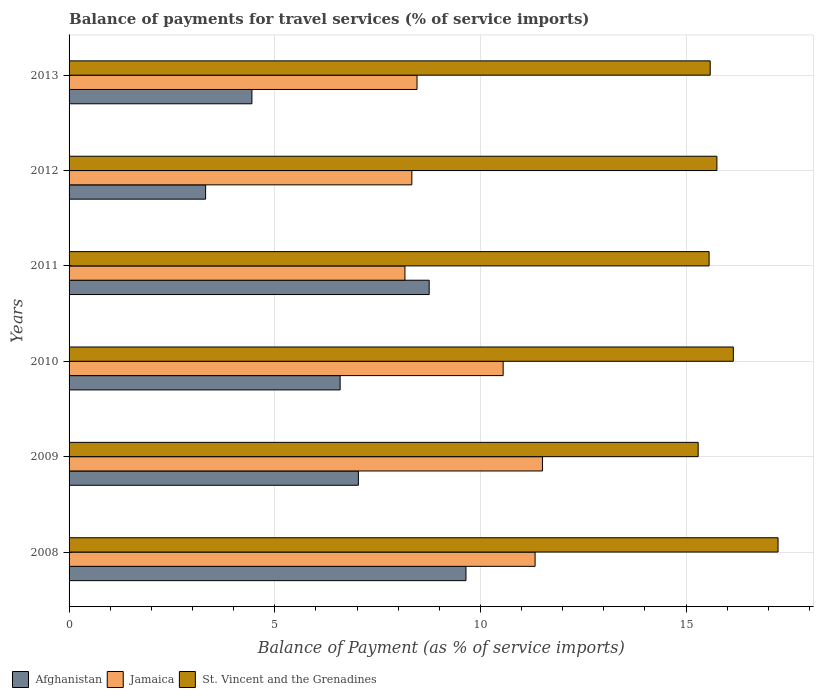How many different coloured bars are there?
Give a very brief answer. 3. How many groups of bars are there?
Your answer should be compact. 6. Are the number of bars per tick equal to the number of legend labels?
Offer a terse response. Yes. How many bars are there on the 5th tick from the top?
Your answer should be very brief. 3. How many bars are there on the 3rd tick from the bottom?
Ensure brevity in your answer.  3. What is the label of the 6th group of bars from the top?
Make the answer very short. 2008. What is the balance of payments for travel services in Jamaica in 2009?
Offer a terse response. 11.51. Across all years, what is the maximum balance of payments for travel services in St. Vincent and the Grenadines?
Keep it short and to the point. 17.24. Across all years, what is the minimum balance of payments for travel services in St. Vincent and the Grenadines?
Provide a succinct answer. 15.29. In which year was the balance of payments for travel services in Afghanistan maximum?
Offer a terse response. 2008. What is the total balance of payments for travel services in Afghanistan in the graph?
Make the answer very short. 39.79. What is the difference between the balance of payments for travel services in St. Vincent and the Grenadines in 2008 and that in 2013?
Offer a terse response. 1.65. What is the difference between the balance of payments for travel services in Jamaica in 2011 and the balance of payments for travel services in St. Vincent and the Grenadines in 2008?
Your answer should be very brief. -9.07. What is the average balance of payments for travel services in St. Vincent and the Grenadines per year?
Keep it short and to the point. 15.93. In the year 2008, what is the difference between the balance of payments for travel services in Jamaica and balance of payments for travel services in Afghanistan?
Make the answer very short. 1.68. What is the ratio of the balance of payments for travel services in Jamaica in 2008 to that in 2012?
Ensure brevity in your answer.  1.36. Is the balance of payments for travel services in St. Vincent and the Grenadines in 2011 less than that in 2012?
Your answer should be very brief. Yes. What is the difference between the highest and the second highest balance of payments for travel services in Afghanistan?
Your answer should be compact. 0.89. What is the difference between the highest and the lowest balance of payments for travel services in Afghanistan?
Your response must be concise. 6.33. In how many years, is the balance of payments for travel services in Jamaica greater than the average balance of payments for travel services in Jamaica taken over all years?
Your response must be concise. 3. What does the 1st bar from the top in 2012 represents?
Your response must be concise. St. Vincent and the Grenadines. What does the 3rd bar from the bottom in 2013 represents?
Your response must be concise. St. Vincent and the Grenadines. How many bars are there?
Keep it short and to the point. 18. What is the difference between two consecutive major ticks on the X-axis?
Your answer should be very brief. 5. Are the values on the major ticks of X-axis written in scientific E-notation?
Your answer should be very brief. No. Does the graph contain any zero values?
Provide a succinct answer. No. What is the title of the graph?
Your response must be concise. Balance of payments for travel services (% of service imports). Does "Faeroe Islands" appear as one of the legend labels in the graph?
Your response must be concise. No. What is the label or title of the X-axis?
Your response must be concise. Balance of Payment (as % of service imports). What is the label or title of the Y-axis?
Offer a very short reply. Years. What is the Balance of Payment (as % of service imports) in Afghanistan in 2008?
Your response must be concise. 9.65. What is the Balance of Payment (as % of service imports) of Jamaica in 2008?
Offer a terse response. 11.33. What is the Balance of Payment (as % of service imports) in St. Vincent and the Grenadines in 2008?
Offer a very short reply. 17.24. What is the Balance of Payment (as % of service imports) of Afghanistan in 2009?
Ensure brevity in your answer.  7.03. What is the Balance of Payment (as % of service imports) in Jamaica in 2009?
Your answer should be compact. 11.51. What is the Balance of Payment (as % of service imports) of St. Vincent and the Grenadines in 2009?
Ensure brevity in your answer.  15.29. What is the Balance of Payment (as % of service imports) in Afghanistan in 2010?
Provide a succinct answer. 6.59. What is the Balance of Payment (as % of service imports) in Jamaica in 2010?
Your response must be concise. 10.55. What is the Balance of Payment (as % of service imports) in St. Vincent and the Grenadines in 2010?
Provide a short and direct response. 16.15. What is the Balance of Payment (as % of service imports) of Afghanistan in 2011?
Offer a very short reply. 8.75. What is the Balance of Payment (as % of service imports) of Jamaica in 2011?
Your answer should be compact. 8.17. What is the Balance of Payment (as % of service imports) in St. Vincent and the Grenadines in 2011?
Give a very brief answer. 15.56. What is the Balance of Payment (as % of service imports) of Afghanistan in 2012?
Give a very brief answer. 3.32. What is the Balance of Payment (as % of service imports) of Jamaica in 2012?
Your response must be concise. 8.33. What is the Balance of Payment (as % of service imports) of St. Vincent and the Grenadines in 2012?
Provide a short and direct response. 15.75. What is the Balance of Payment (as % of service imports) in Afghanistan in 2013?
Your response must be concise. 4.45. What is the Balance of Payment (as % of service imports) in Jamaica in 2013?
Your answer should be compact. 8.46. What is the Balance of Payment (as % of service imports) in St. Vincent and the Grenadines in 2013?
Ensure brevity in your answer.  15.59. Across all years, what is the maximum Balance of Payment (as % of service imports) in Afghanistan?
Keep it short and to the point. 9.65. Across all years, what is the maximum Balance of Payment (as % of service imports) of Jamaica?
Offer a very short reply. 11.51. Across all years, what is the maximum Balance of Payment (as % of service imports) in St. Vincent and the Grenadines?
Offer a terse response. 17.24. Across all years, what is the minimum Balance of Payment (as % of service imports) of Afghanistan?
Provide a short and direct response. 3.32. Across all years, what is the minimum Balance of Payment (as % of service imports) of Jamaica?
Your answer should be very brief. 8.17. Across all years, what is the minimum Balance of Payment (as % of service imports) in St. Vincent and the Grenadines?
Keep it short and to the point. 15.29. What is the total Balance of Payment (as % of service imports) of Afghanistan in the graph?
Offer a terse response. 39.79. What is the total Balance of Payment (as % of service imports) of Jamaica in the graph?
Your answer should be compact. 58.35. What is the total Balance of Payment (as % of service imports) in St. Vincent and the Grenadines in the graph?
Your answer should be very brief. 95.57. What is the difference between the Balance of Payment (as % of service imports) in Afghanistan in 2008 and that in 2009?
Give a very brief answer. 2.62. What is the difference between the Balance of Payment (as % of service imports) of Jamaica in 2008 and that in 2009?
Make the answer very short. -0.18. What is the difference between the Balance of Payment (as % of service imports) in St. Vincent and the Grenadines in 2008 and that in 2009?
Offer a terse response. 1.94. What is the difference between the Balance of Payment (as % of service imports) of Afghanistan in 2008 and that in 2010?
Offer a terse response. 3.06. What is the difference between the Balance of Payment (as % of service imports) in Jamaica in 2008 and that in 2010?
Keep it short and to the point. 0.78. What is the difference between the Balance of Payment (as % of service imports) in St. Vincent and the Grenadines in 2008 and that in 2010?
Make the answer very short. 1.09. What is the difference between the Balance of Payment (as % of service imports) of Afghanistan in 2008 and that in 2011?
Provide a short and direct response. 0.89. What is the difference between the Balance of Payment (as % of service imports) in Jamaica in 2008 and that in 2011?
Offer a very short reply. 3.16. What is the difference between the Balance of Payment (as % of service imports) of St. Vincent and the Grenadines in 2008 and that in 2011?
Ensure brevity in your answer.  1.68. What is the difference between the Balance of Payment (as % of service imports) of Afghanistan in 2008 and that in 2012?
Provide a short and direct response. 6.33. What is the difference between the Balance of Payment (as % of service imports) of Jamaica in 2008 and that in 2012?
Make the answer very short. 3. What is the difference between the Balance of Payment (as % of service imports) of St. Vincent and the Grenadines in 2008 and that in 2012?
Offer a terse response. 1.49. What is the difference between the Balance of Payment (as % of service imports) in Afghanistan in 2008 and that in 2013?
Offer a very short reply. 5.2. What is the difference between the Balance of Payment (as % of service imports) in Jamaica in 2008 and that in 2013?
Your answer should be very brief. 2.87. What is the difference between the Balance of Payment (as % of service imports) in St. Vincent and the Grenadines in 2008 and that in 2013?
Ensure brevity in your answer.  1.65. What is the difference between the Balance of Payment (as % of service imports) in Afghanistan in 2009 and that in 2010?
Provide a succinct answer. 0.44. What is the difference between the Balance of Payment (as % of service imports) of Jamaica in 2009 and that in 2010?
Provide a short and direct response. 0.96. What is the difference between the Balance of Payment (as % of service imports) in St. Vincent and the Grenadines in 2009 and that in 2010?
Provide a succinct answer. -0.85. What is the difference between the Balance of Payment (as % of service imports) in Afghanistan in 2009 and that in 2011?
Provide a succinct answer. -1.72. What is the difference between the Balance of Payment (as % of service imports) of Jamaica in 2009 and that in 2011?
Keep it short and to the point. 3.34. What is the difference between the Balance of Payment (as % of service imports) of St. Vincent and the Grenadines in 2009 and that in 2011?
Your response must be concise. -0.27. What is the difference between the Balance of Payment (as % of service imports) in Afghanistan in 2009 and that in 2012?
Provide a short and direct response. 3.71. What is the difference between the Balance of Payment (as % of service imports) of Jamaica in 2009 and that in 2012?
Ensure brevity in your answer.  3.18. What is the difference between the Balance of Payment (as % of service imports) of St. Vincent and the Grenadines in 2009 and that in 2012?
Offer a very short reply. -0.46. What is the difference between the Balance of Payment (as % of service imports) of Afghanistan in 2009 and that in 2013?
Ensure brevity in your answer.  2.59. What is the difference between the Balance of Payment (as % of service imports) in Jamaica in 2009 and that in 2013?
Your answer should be compact. 3.05. What is the difference between the Balance of Payment (as % of service imports) of St. Vincent and the Grenadines in 2009 and that in 2013?
Your response must be concise. -0.29. What is the difference between the Balance of Payment (as % of service imports) of Afghanistan in 2010 and that in 2011?
Offer a terse response. -2.16. What is the difference between the Balance of Payment (as % of service imports) of Jamaica in 2010 and that in 2011?
Your response must be concise. 2.39. What is the difference between the Balance of Payment (as % of service imports) in St. Vincent and the Grenadines in 2010 and that in 2011?
Give a very brief answer. 0.59. What is the difference between the Balance of Payment (as % of service imports) in Afghanistan in 2010 and that in 2012?
Keep it short and to the point. 3.27. What is the difference between the Balance of Payment (as % of service imports) of Jamaica in 2010 and that in 2012?
Give a very brief answer. 2.22. What is the difference between the Balance of Payment (as % of service imports) of St. Vincent and the Grenadines in 2010 and that in 2012?
Ensure brevity in your answer.  0.4. What is the difference between the Balance of Payment (as % of service imports) of Afghanistan in 2010 and that in 2013?
Give a very brief answer. 2.14. What is the difference between the Balance of Payment (as % of service imports) of Jamaica in 2010 and that in 2013?
Offer a terse response. 2.09. What is the difference between the Balance of Payment (as % of service imports) of St. Vincent and the Grenadines in 2010 and that in 2013?
Ensure brevity in your answer.  0.56. What is the difference between the Balance of Payment (as % of service imports) in Afghanistan in 2011 and that in 2012?
Ensure brevity in your answer.  5.44. What is the difference between the Balance of Payment (as % of service imports) in Jamaica in 2011 and that in 2012?
Offer a very short reply. -0.17. What is the difference between the Balance of Payment (as % of service imports) of St. Vincent and the Grenadines in 2011 and that in 2012?
Your response must be concise. -0.19. What is the difference between the Balance of Payment (as % of service imports) in Afghanistan in 2011 and that in 2013?
Your answer should be compact. 4.31. What is the difference between the Balance of Payment (as % of service imports) in Jamaica in 2011 and that in 2013?
Give a very brief answer. -0.29. What is the difference between the Balance of Payment (as % of service imports) of St. Vincent and the Grenadines in 2011 and that in 2013?
Provide a succinct answer. -0.03. What is the difference between the Balance of Payment (as % of service imports) in Afghanistan in 2012 and that in 2013?
Your answer should be compact. -1.13. What is the difference between the Balance of Payment (as % of service imports) in Jamaica in 2012 and that in 2013?
Offer a very short reply. -0.13. What is the difference between the Balance of Payment (as % of service imports) in St. Vincent and the Grenadines in 2012 and that in 2013?
Keep it short and to the point. 0.16. What is the difference between the Balance of Payment (as % of service imports) in Afghanistan in 2008 and the Balance of Payment (as % of service imports) in Jamaica in 2009?
Offer a very short reply. -1.86. What is the difference between the Balance of Payment (as % of service imports) of Afghanistan in 2008 and the Balance of Payment (as % of service imports) of St. Vincent and the Grenadines in 2009?
Provide a short and direct response. -5.64. What is the difference between the Balance of Payment (as % of service imports) in Jamaica in 2008 and the Balance of Payment (as % of service imports) in St. Vincent and the Grenadines in 2009?
Give a very brief answer. -3.96. What is the difference between the Balance of Payment (as % of service imports) of Afghanistan in 2008 and the Balance of Payment (as % of service imports) of Jamaica in 2010?
Give a very brief answer. -0.9. What is the difference between the Balance of Payment (as % of service imports) of Afghanistan in 2008 and the Balance of Payment (as % of service imports) of St. Vincent and the Grenadines in 2010?
Keep it short and to the point. -6.5. What is the difference between the Balance of Payment (as % of service imports) of Jamaica in 2008 and the Balance of Payment (as % of service imports) of St. Vincent and the Grenadines in 2010?
Your answer should be compact. -4.82. What is the difference between the Balance of Payment (as % of service imports) in Afghanistan in 2008 and the Balance of Payment (as % of service imports) in Jamaica in 2011?
Your answer should be compact. 1.48. What is the difference between the Balance of Payment (as % of service imports) in Afghanistan in 2008 and the Balance of Payment (as % of service imports) in St. Vincent and the Grenadines in 2011?
Your response must be concise. -5.91. What is the difference between the Balance of Payment (as % of service imports) in Jamaica in 2008 and the Balance of Payment (as % of service imports) in St. Vincent and the Grenadines in 2011?
Provide a succinct answer. -4.23. What is the difference between the Balance of Payment (as % of service imports) of Afghanistan in 2008 and the Balance of Payment (as % of service imports) of Jamaica in 2012?
Your answer should be very brief. 1.32. What is the difference between the Balance of Payment (as % of service imports) of Afghanistan in 2008 and the Balance of Payment (as % of service imports) of St. Vincent and the Grenadines in 2012?
Provide a succinct answer. -6.1. What is the difference between the Balance of Payment (as % of service imports) in Jamaica in 2008 and the Balance of Payment (as % of service imports) in St. Vincent and the Grenadines in 2012?
Make the answer very short. -4.42. What is the difference between the Balance of Payment (as % of service imports) of Afghanistan in 2008 and the Balance of Payment (as % of service imports) of Jamaica in 2013?
Your response must be concise. 1.19. What is the difference between the Balance of Payment (as % of service imports) in Afghanistan in 2008 and the Balance of Payment (as % of service imports) in St. Vincent and the Grenadines in 2013?
Provide a short and direct response. -5.94. What is the difference between the Balance of Payment (as % of service imports) of Jamaica in 2008 and the Balance of Payment (as % of service imports) of St. Vincent and the Grenadines in 2013?
Your response must be concise. -4.26. What is the difference between the Balance of Payment (as % of service imports) of Afghanistan in 2009 and the Balance of Payment (as % of service imports) of Jamaica in 2010?
Your answer should be very brief. -3.52. What is the difference between the Balance of Payment (as % of service imports) of Afghanistan in 2009 and the Balance of Payment (as % of service imports) of St. Vincent and the Grenadines in 2010?
Offer a terse response. -9.12. What is the difference between the Balance of Payment (as % of service imports) in Jamaica in 2009 and the Balance of Payment (as % of service imports) in St. Vincent and the Grenadines in 2010?
Ensure brevity in your answer.  -4.64. What is the difference between the Balance of Payment (as % of service imports) in Afghanistan in 2009 and the Balance of Payment (as % of service imports) in Jamaica in 2011?
Your answer should be compact. -1.13. What is the difference between the Balance of Payment (as % of service imports) of Afghanistan in 2009 and the Balance of Payment (as % of service imports) of St. Vincent and the Grenadines in 2011?
Offer a very short reply. -8.53. What is the difference between the Balance of Payment (as % of service imports) in Jamaica in 2009 and the Balance of Payment (as % of service imports) in St. Vincent and the Grenadines in 2011?
Offer a terse response. -4.05. What is the difference between the Balance of Payment (as % of service imports) in Afghanistan in 2009 and the Balance of Payment (as % of service imports) in Jamaica in 2012?
Keep it short and to the point. -1.3. What is the difference between the Balance of Payment (as % of service imports) of Afghanistan in 2009 and the Balance of Payment (as % of service imports) of St. Vincent and the Grenadines in 2012?
Keep it short and to the point. -8.72. What is the difference between the Balance of Payment (as % of service imports) in Jamaica in 2009 and the Balance of Payment (as % of service imports) in St. Vincent and the Grenadines in 2012?
Provide a succinct answer. -4.24. What is the difference between the Balance of Payment (as % of service imports) in Afghanistan in 2009 and the Balance of Payment (as % of service imports) in Jamaica in 2013?
Your answer should be compact. -1.43. What is the difference between the Balance of Payment (as % of service imports) in Afghanistan in 2009 and the Balance of Payment (as % of service imports) in St. Vincent and the Grenadines in 2013?
Your response must be concise. -8.55. What is the difference between the Balance of Payment (as % of service imports) in Jamaica in 2009 and the Balance of Payment (as % of service imports) in St. Vincent and the Grenadines in 2013?
Your answer should be compact. -4.08. What is the difference between the Balance of Payment (as % of service imports) of Afghanistan in 2010 and the Balance of Payment (as % of service imports) of Jamaica in 2011?
Offer a terse response. -1.58. What is the difference between the Balance of Payment (as % of service imports) of Afghanistan in 2010 and the Balance of Payment (as % of service imports) of St. Vincent and the Grenadines in 2011?
Keep it short and to the point. -8.97. What is the difference between the Balance of Payment (as % of service imports) in Jamaica in 2010 and the Balance of Payment (as % of service imports) in St. Vincent and the Grenadines in 2011?
Keep it short and to the point. -5.01. What is the difference between the Balance of Payment (as % of service imports) of Afghanistan in 2010 and the Balance of Payment (as % of service imports) of Jamaica in 2012?
Your response must be concise. -1.74. What is the difference between the Balance of Payment (as % of service imports) of Afghanistan in 2010 and the Balance of Payment (as % of service imports) of St. Vincent and the Grenadines in 2012?
Keep it short and to the point. -9.16. What is the difference between the Balance of Payment (as % of service imports) of Jamaica in 2010 and the Balance of Payment (as % of service imports) of St. Vincent and the Grenadines in 2012?
Provide a short and direct response. -5.2. What is the difference between the Balance of Payment (as % of service imports) in Afghanistan in 2010 and the Balance of Payment (as % of service imports) in Jamaica in 2013?
Your response must be concise. -1.87. What is the difference between the Balance of Payment (as % of service imports) in Afghanistan in 2010 and the Balance of Payment (as % of service imports) in St. Vincent and the Grenadines in 2013?
Offer a very short reply. -9. What is the difference between the Balance of Payment (as % of service imports) in Jamaica in 2010 and the Balance of Payment (as % of service imports) in St. Vincent and the Grenadines in 2013?
Make the answer very short. -5.03. What is the difference between the Balance of Payment (as % of service imports) of Afghanistan in 2011 and the Balance of Payment (as % of service imports) of Jamaica in 2012?
Give a very brief answer. 0.42. What is the difference between the Balance of Payment (as % of service imports) in Afghanistan in 2011 and the Balance of Payment (as % of service imports) in St. Vincent and the Grenadines in 2012?
Your answer should be compact. -6.99. What is the difference between the Balance of Payment (as % of service imports) of Jamaica in 2011 and the Balance of Payment (as % of service imports) of St. Vincent and the Grenadines in 2012?
Your answer should be very brief. -7.58. What is the difference between the Balance of Payment (as % of service imports) in Afghanistan in 2011 and the Balance of Payment (as % of service imports) in Jamaica in 2013?
Provide a short and direct response. 0.3. What is the difference between the Balance of Payment (as % of service imports) in Afghanistan in 2011 and the Balance of Payment (as % of service imports) in St. Vincent and the Grenadines in 2013?
Your answer should be very brief. -6.83. What is the difference between the Balance of Payment (as % of service imports) of Jamaica in 2011 and the Balance of Payment (as % of service imports) of St. Vincent and the Grenadines in 2013?
Your answer should be compact. -7.42. What is the difference between the Balance of Payment (as % of service imports) in Afghanistan in 2012 and the Balance of Payment (as % of service imports) in Jamaica in 2013?
Make the answer very short. -5.14. What is the difference between the Balance of Payment (as % of service imports) of Afghanistan in 2012 and the Balance of Payment (as % of service imports) of St. Vincent and the Grenadines in 2013?
Give a very brief answer. -12.27. What is the difference between the Balance of Payment (as % of service imports) in Jamaica in 2012 and the Balance of Payment (as % of service imports) in St. Vincent and the Grenadines in 2013?
Make the answer very short. -7.25. What is the average Balance of Payment (as % of service imports) in Afghanistan per year?
Ensure brevity in your answer.  6.63. What is the average Balance of Payment (as % of service imports) of Jamaica per year?
Provide a succinct answer. 9.72. What is the average Balance of Payment (as % of service imports) of St. Vincent and the Grenadines per year?
Your answer should be very brief. 15.93. In the year 2008, what is the difference between the Balance of Payment (as % of service imports) of Afghanistan and Balance of Payment (as % of service imports) of Jamaica?
Provide a short and direct response. -1.68. In the year 2008, what is the difference between the Balance of Payment (as % of service imports) in Afghanistan and Balance of Payment (as % of service imports) in St. Vincent and the Grenadines?
Keep it short and to the point. -7.59. In the year 2008, what is the difference between the Balance of Payment (as % of service imports) in Jamaica and Balance of Payment (as % of service imports) in St. Vincent and the Grenadines?
Make the answer very short. -5.91. In the year 2009, what is the difference between the Balance of Payment (as % of service imports) in Afghanistan and Balance of Payment (as % of service imports) in Jamaica?
Offer a very short reply. -4.48. In the year 2009, what is the difference between the Balance of Payment (as % of service imports) of Afghanistan and Balance of Payment (as % of service imports) of St. Vincent and the Grenadines?
Ensure brevity in your answer.  -8.26. In the year 2009, what is the difference between the Balance of Payment (as % of service imports) of Jamaica and Balance of Payment (as % of service imports) of St. Vincent and the Grenadines?
Provide a succinct answer. -3.79. In the year 2010, what is the difference between the Balance of Payment (as % of service imports) in Afghanistan and Balance of Payment (as % of service imports) in Jamaica?
Your response must be concise. -3.96. In the year 2010, what is the difference between the Balance of Payment (as % of service imports) in Afghanistan and Balance of Payment (as % of service imports) in St. Vincent and the Grenadines?
Your answer should be compact. -9.56. In the year 2010, what is the difference between the Balance of Payment (as % of service imports) of Jamaica and Balance of Payment (as % of service imports) of St. Vincent and the Grenadines?
Make the answer very short. -5.6. In the year 2011, what is the difference between the Balance of Payment (as % of service imports) of Afghanistan and Balance of Payment (as % of service imports) of Jamaica?
Your response must be concise. 0.59. In the year 2011, what is the difference between the Balance of Payment (as % of service imports) of Afghanistan and Balance of Payment (as % of service imports) of St. Vincent and the Grenadines?
Your answer should be compact. -6.8. In the year 2011, what is the difference between the Balance of Payment (as % of service imports) of Jamaica and Balance of Payment (as % of service imports) of St. Vincent and the Grenadines?
Your response must be concise. -7.39. In the year 2012, what is the difference between the Balance of Payment (as % of service imports) of Afghanistan and Balance of Payment (as % of service imports) of Jamaica?
Ensure brevity in your answer.  -5.01. In the year 2012, what is the difference between the Balance of Payment (as % of service imports) in Afghanistan and Balance of Payment (as % of service imports) in St. Vincent and the Grenadines?
Provide a succinct answer. -12.43. In the year 2012, what is the difference between the Balance of Payment (as % of service imports) in Jamaica and Balance of Payment (as % of service imports) in St. Vincent and the Grenadines?
Offer a terse response. -7.42. In the year 2013, what is the difference between the Balance of Payment (as % of service imports) of Afghanistan and Balance of Payment (as % of service imports) of Jamaica?
Keep it short and to the point. -4.01. In the year 2013, what is the difference between the Balance of Payment (as % of service imports) in Afghanistan and Balance of Payment (as % of service imports) in St. Vincent and the Grenadines?
Your response must be concise. -11.14. In the year 2013, what is the difference between the Balance of Payment (as % of service imports) in Jamaica and Balance of Payment (as % of service imports) in St. Vincent and the Grenadines?
Ensure brevity in your answer.  -7.13. What is the ratio of the Balance of Payment (as % of service imports) of Afghanistan in 2008 to that in 2009?
Ensure brevity in your answer.  1.37. What is the ratio of the Balance of Payment (as % of service imports) of Jamaica in 2008 to that in 2009?
Ensure brevity in your answer.  0.98. What is the ratio of the Balance of Payment (as % of service imports) of St. Vincent and the Grenadines in 2008 to that in 2009?
Your answer should be compact. 1.13. What is the ratio of the Balance of Payment (as % of service imports) in Afghanistan in 2008 to that in 2010?
Ensure brevity in your answer.  1.46. What is the ratio of the Balance of Payment (as % of service imports) in Jamaica in 2008 to that in 2010?
Offer a terse response. 1.07. What is the ratio of the Balance of Payment (as % of service imports) of St. Vincent and the Grenadines in 2008 to that in 2010?
Keep it short and to the point. 1.07. What is the ratio of the Balance of Payment (as % of service imports) of Afghanistan in 2008 to that in 2011?
Offer a very short reply. 1.1. What is the ratio of the Balance of Payment (as % of service imports) in Jamaica in 2008 to that in 2011?
Offer a very short reply. 1.39. What is the ratio of the Balance of Payment (as % of service imports) of St. Vincent and the Grenadines in 2008 to that in 2011?
Give a very brief answer. 1.11. What is the ratio of the Balance of Payment (as % of service imports) in Afghanistan in 2008 to that in 2012?
Your answer should be very brief. 2.91. What is the ratio of the Balance of Payment (as % of service imports) in Jamaica in 2008 to that in 2012?
Your response must be concise. 1.36. What is the ratio of the Balance of Payment (as % of service imports) of St. Vincent and the Grenadines in 2008 to that in 2012?
Your response must be concise. 1.09. What is the ratio of the Balance of Payment (as % of service imports) of Afghanistan in 2008 to that in 2013?
Provide a short and direct response. 2.17. What is the ratio of the Balance of Payment (as % of service imports) of Jamaica in 2008 to that in 2013?
Your answer should be compact. 1.34. What is the ratio of the Balance of Payment (as % of service imports) of St. Vincent and the Grenadines in 2008 to that in 2013?
Offer a very short reply. 1.11. What is the ratio of the Balance of Payment (as % of service imports) in Afghanistan in 2009 to that in 2010?
Keep it short and to the point. 1.07. What is the ratio of the Balance of Payment (as % of service imports) of Jamaica in 2009 to that in 2010?
Your response must be concise. 1.09. What is the ratio of the Balance of Payment (as % of service imports) of St. Vincent and the Grenadines in 2009 to that in 2010?
Your answer should be very brief. 0.95. What is the ratio of the Balance of Payment (as % of service imports) in Afghanistan in 2009 to that in 2011?
Your response must be concise. 0.8. What is the ratio of the Balance of Payment (as % of service imports) in Jamaica in 2009 to that in 2011?
Provide a short and direct response. 1.41. What is the ratio of the Balance of Payment (as % of service imports) of St. Vincent and the Grenadines in 2009 to that in 2011?
Provide a short and direct response. 0.98. What is the ratio of the Balance of Payment (as % of service imports) of Afghanistan in 2009 to that in 2012?
Your answer should be very brief. 2.12. What is the ratio of the Balance of Payment (as % of service imports) of Jamaica in 2009 to that in 2012?
Your response must be concise. 1.38. What is the ratio of the Balance of Payment (as % of service imports) in St. Vincent and the Grenadines in 2009 to that in 2012?
Keep it short and to the point. 0.97. What is the ratio of the Balance of Payment (as % of service imports) of Afghanistan in 2009 to that in 2013?
Your answer should be compact. 1.58. What is the ratio of the Balance of Payment (as % of service imports) of Jamaica in 2009 to that in 2013?
Your response must be concise. 1.36. What is the ratio of the Balance of Payment (as % of service imports) of St. Vincent and the Grenadines in 2009 to that in 2013?
Ensure brevity in your answer.  0.98. What is the ratio of the Balance of Payment (as % of service imports) of Afghanistan in 2010 to that in 2011?
Your answer should be very brief. 0.75. What is the ratio of the Balance of Payment (as % of service imports) of Jamaica in 2010 to that in 2011?
Your response must be concise. 1.29. What is the ratio of the Balance of Payment (as % of service imports) of St. Vincent and the Grenadines in 2010 to that in 2011?
Your response must be concise. 1.04. What is the ratio of the Balance of Payment (as % of service imports) in Afghanistan in 2010 to that in 2012?
Your answer should be compact. 1.99. What is the ratio of the Balance of Payment (as % of service imports) in Jamaica in 2010 to that in 2012?
Ensure brevity in your answer.  1.27. What is the ratio of the Balance of Payment (as % of service imports) of St. Vincent and the Grenadines in 2010 to that in 2012?
Give a very brief answer. 1.03. What is the ratio of the Balance of Payment (as % of service imports) in Afghanistan in 2010 to that in 2013?
Your response must be concise. 1.48. What is the ratio of the Balance of Payment (as % of service imports) of Jamaica in 2010 to that in 2013?
Offer a terse response. 1.25. What is the ratio of the Balance of Payment (as % of service imports) in St. Vincent and the Grenadines in 2010 to that in 2013?
Give a very brief answer. 1.04. What is the ratio of the Balance of Payment (as % of service imports) in Afghanistan in 2011 to that in 2012?
Your answer should be very brief. 2.64. What is the ratio of the Balance of Payment (as % of service imports) of Jamaica in 2011 to that in 2012?
Provide a short and direct response. 0.98. What is the ratio of the Balance of Payment (as % of service imports) of St. Vincent and the Grenadines in 2011 to that in 2012?
Your answer should be compact. 0.99. What is the ratio of the Balance of Payment (as % of service imports) in Afghanistan in 2011 to that in 2013?
Give a very brief answer. 1.97. What is the ratio of the Balance of Payment (as % of service imports) of Jamaica in 2011 to that in 2013?
Offer a terse response. 0.97. What is the ratio of the Balance of Payment (as % of service imports) of St. Vincent and the Grenadines in 2011 to that in 2013?
Your answer should be compact. 1. What is the ratio of the Balance of Payment (as % of service imports) of Afghanistan in 2012 to that in 2013?
Your answer should be very brief. 0.75. What is the ratio of the Balance of Payment (as % of service imports) of Jamaica in 2012 to that in 2013?
Offer a terse response. 0.99. What is the ratio of the Balance of Payment (as % of service imports) in St. Vincent and the Grenadines in 2012 to that in 2013?
Give a very brief answer. 1.01. What is the difference between the highest and the second highest Balance of Payment (as % of service imports) of Afghanistan?
Your answer should be very brief. 0.89. What is the difference between the highest and the second highest Balance of Payment (as % of service imports) in Jamaica?
Your response must be concise. 0.18. What is the difference between the highest and the second highest Balance of Payment (as % of service imports) in St. Vincent and the Grenadines?
Your response must be concise. 1.09. What is the difference between the highest and the lowest Balance of Payment (as % of service imports) of Afghanistan?
Provide a short and direct response. 6.33. What is the difference between the highest and the lowest Balance of Payment (as % of service imports) of Jamaica?
Your response must be concise. 3.34. What is the difference between the highest and the lowest Balance of Payment (as % of service imports) in St. Vincent and the Grenadines?
Provide a short and direct response. 1.94. 